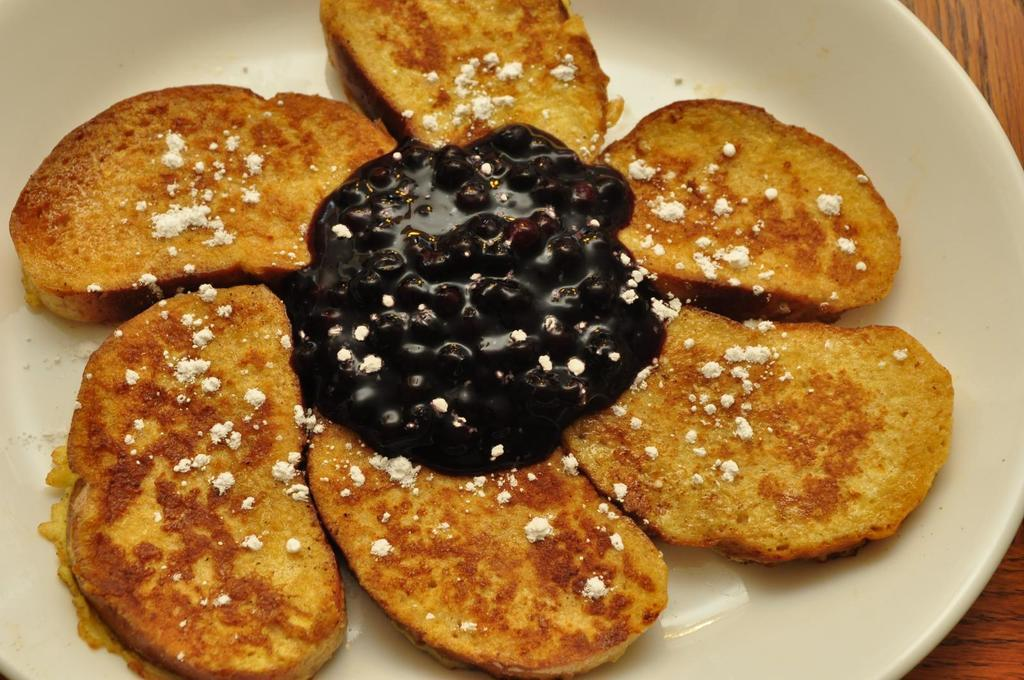What is on the plate that is visible in the image? The plate contains toast and fruit jam. Where is the plate located in the image? The plate is placed on a table. What type of setting is the image likely taken in? The image is likely taken in a room. How many people are joining in to eat the cake in the image? There is no cake present in the image, so it is not possible to answer that question. 